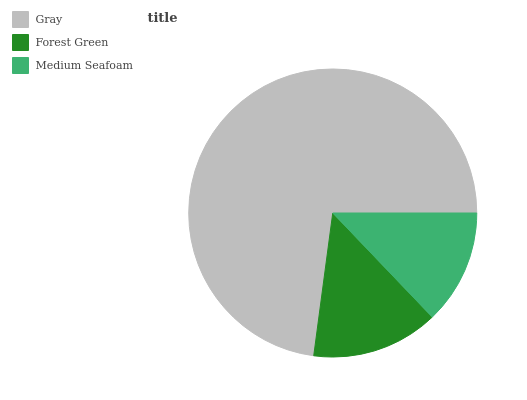Is Medium Seafoam the minimum?
Answer yes or no. Yes. Is Gray the maximum?
Answer yes or no. Yes. Is Forest Green the minimum?
Answer yes or no. No. Is Forest Green the maximum?
Answer yes or no. No. Is Gray greater than Forest Green?
Answer yes or no. Yes. Is Forest Green less than Gray?
Answer yes or no. Yes. Is Forest Green greater than Gray?
Answer yes or no. No. Is Gray less than Forest Green?
Answer yes or no. No. Is Forest Green the high median?
Answer yes or no. Yes. Is Forest Green the low median?
Answer yes or no. Yes. Is Medium Seafoam the high median?
Answer yes or no. No. Is Gray the low median?
Answer yes or no. No. 